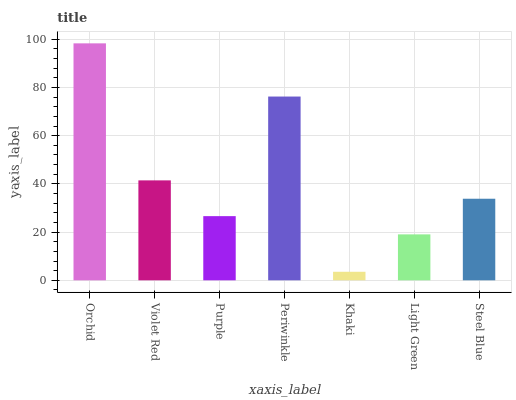Is Khaki the minimum?
Answer yes or no. Yes. Is Orchid the maximum?
Answer yes or no. Yes. Is Violet Red the minimum?
Answer yes or no. No. Is Violet Red the maximum?
Answer yes or no. No. Is Orchid greater than Violet Red?
Answer yes or no. Yes. Is Violet Red less than Orchid?
Answer yes or no. Yes. Is Violet Red greater than Orchid?
Answer yes or no. No. Is Orchid less than Violet Red?
Answer yes or no. No. Is Steel Blue the high median?
Answer yes or no. Yes. Is Steel Blue the low median?
Answer yes or no. Yes. Is Khaki the high median?
Answer yes or no. No. Is Khaki the low median?
Answer yes or no. No. 